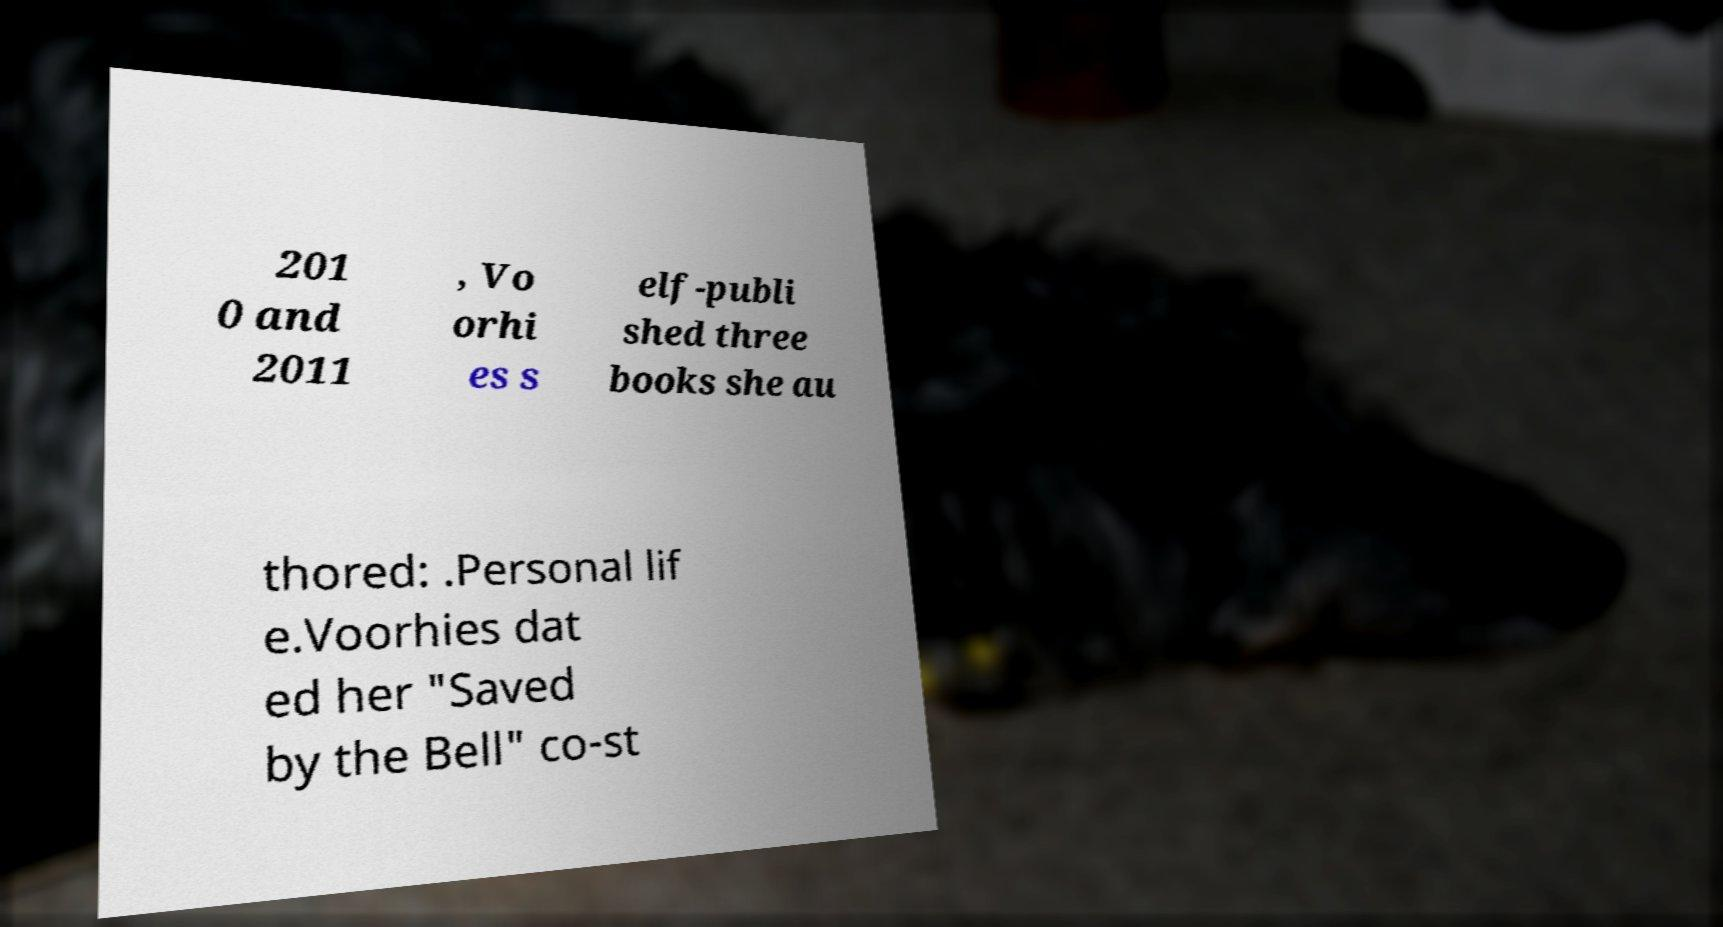For documentation purposes, I need the text within this image transcribed. Could you provide that? 201 0 and 2011 , Vo orhi es s elf-publi shed three books she au thored: .Personal lif e.Voorhies dat ed her "Saved by the Bell" co-st 